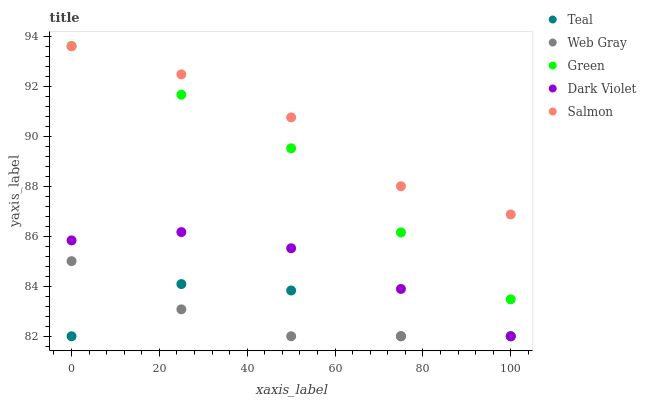Does Web Gray have the minimum area under the curve?
Answer yes or no. Yes. Does Salmon have the maximum area under the curve?
Answer yes or no. Yes. Does Green have the minimum area under the curve?
Answer yes or no. No. Does Green have the maximum area under the curve?
Answer yes or no. No. Is Web Gray the smoothest?
Answer yes or no. Yes. Is Teal the roughest?
Answer yes or no. Yes. Is Green the smoothest?
Answer yes or no. No. Is Green the roughest?
Answer yes or no. No. Does Web Gray have the lowest value?
Answer yes or no. Yes. Does Green have the lowest value?
Answer yes or no. No. Does Green have the highest value?
Answer yes or no. Yes. Does Web Gray have the highest value?
Answer yes or no. No. Is Teal less than Green?
Answer yes or no. Yes. Is Green greater than Web Gray?
Answer yes or no. Yes. Does Web Gray intersect Dark Violet?
Answer yes or no. Yes. Is Web Gray less than Dark Violet?
Answer yes or no. No. Is Web Gray greater than Dark Violet?
Answer yes or no. No. Does Teal intersect Green?
Answer yes or no. No. 